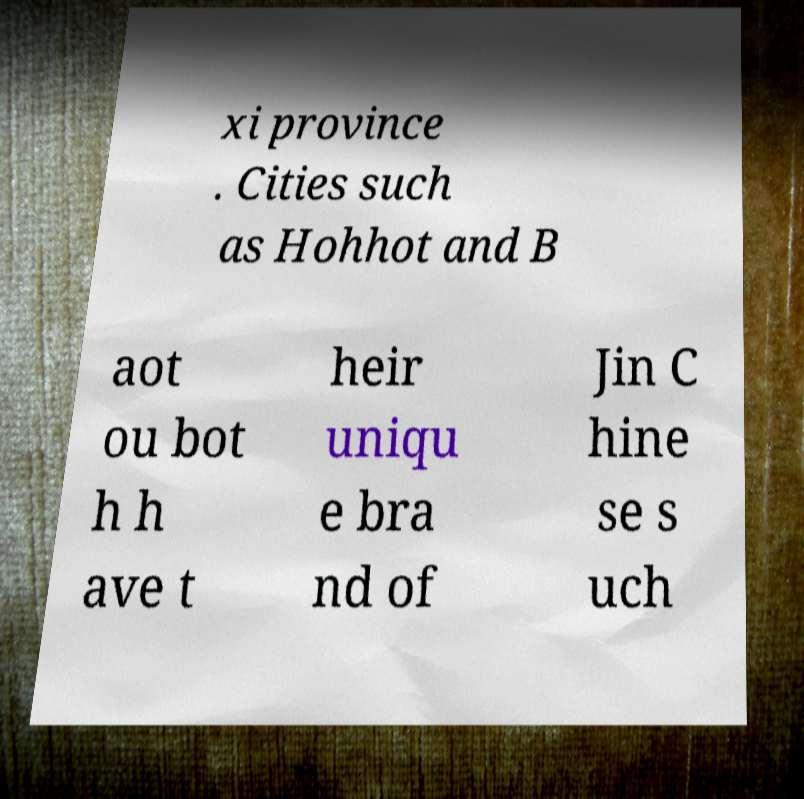Can you read and provide the text displayed in the image?This photo seems to have some interesting text. Can you extract and type it out for me? xi province . Cities such as Hohhot and B aot ou bot h h ave t heir uniqu e bra nd of Jin C hine se s uch 